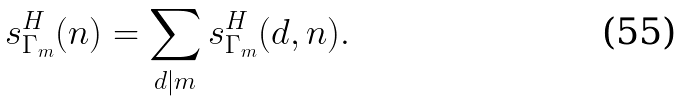<formula> <loc_0><loc_0><loc_500><loc_500>s _ { \Gamma _ { m } } ^ { H } ( n ) = \sum _ { d | m } s _ { \Gamma _ { m } } ^ { H } ( d , n ) .</formula> 